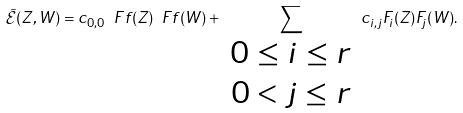Convert formula to latex. <formula><loc_0><loc_0><loc_500><loc_500>\tilde { \mathcal { E } } ( Z , W ) = c _ { 0 , 0 } \ F f ( Z ) \ F f ( W ) + \sum _ { \begin{array} { c } 0 \leq i \leq r \\ 0 < j \leq r \end{array} } c _ { i , j } F _ { i } ( Z ) F _ { j } ( W ) .</formula> 